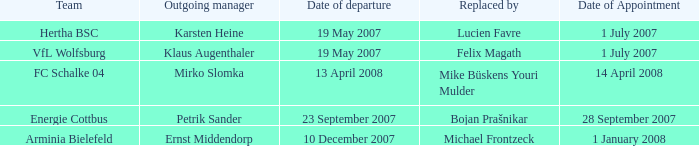When was the appointment date for the manager replaced by Lucien Favre? 1 July 2007. 